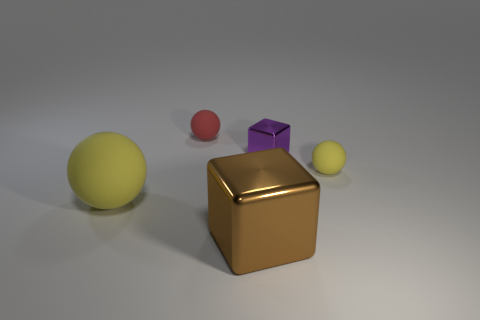Add 1 tiny purple objects. How many objects exist? 6 Subtract all balls. How many objects are left? 2 Add 1 small purple blocks. How many small purple blocks exist? 2 Subtract 0 yellow cylinders. How many objects are left? 5 Subtract all brown cubes. Subtract all tiny purple shiny blocks. How many objects are left? 3 Add 4 tiny yellow things. How many tiny yellow things are left? 5 